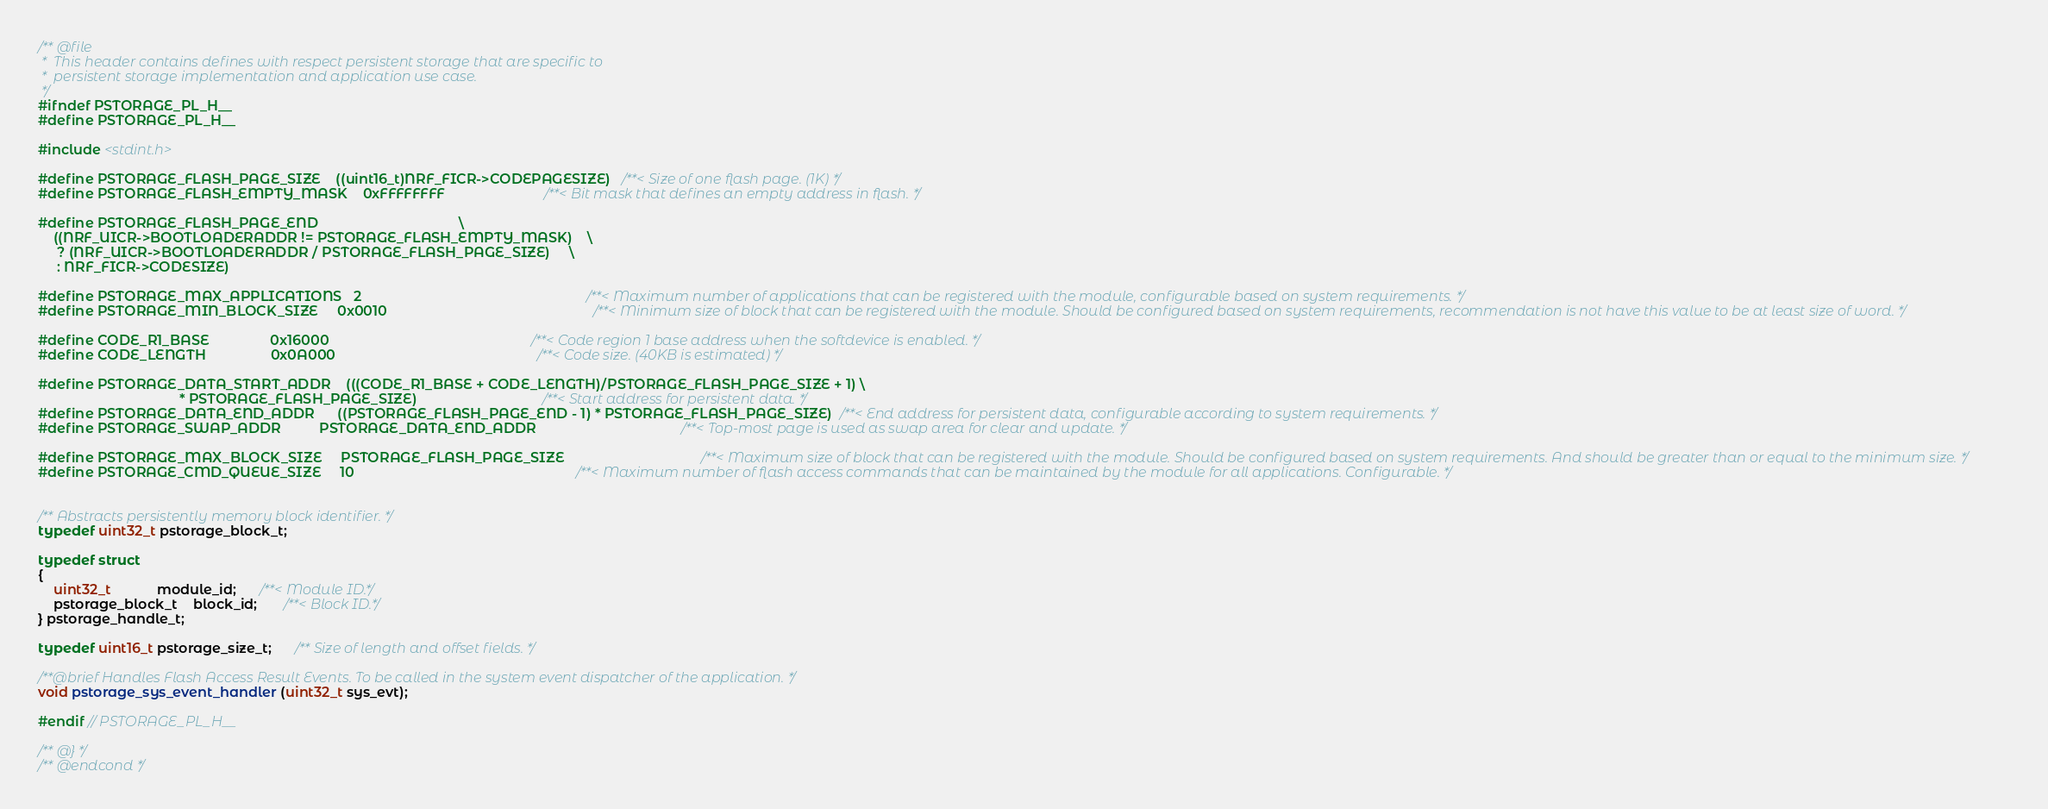Convert code to text. <code><loc_0><loc_0><loc_500><loc_500><_C_>
/** @file
 *  This header contains defines with respect persistent storage that are specific to
 *  persistent storage implementation and application use case.
 */
#ifndef PSTORAGE_PL_H__
#define PSTORAGE_PL_H__

#include <stdint.h>

#define PSTORAGE_FLASH_PAGE_SIZE    ((uint16_t)NRF_FICR->CODEPAGESIZE)   /**< Size of one flash page. (1K) */
#define PSTORAGE_FLASH_EMPTY_MASK    0xFFFFFFFF                          /**< Bit mask that defines an empty address in flash. */

#define PSTORAGE_FLASH_PAGE_END                                     \
    ((NRF_UICR->BOOTLOADERADDR != PSTORAGE_FLASH_EMPTY_MASK)    \
     ? (NRF_UICR->BOOTLOADERADDR / PSTORAGE_FLASH_PAGE_SIZE)     \
     : NRF_FICR->CODESIZE)

#define PSTORAGE_MAX_APPLICATIONS   2                                                           /**< Maximum number of applications that can be registered with the module, configurable based on system requirements. */
#define PSTORAGE_MIN_BLOCK_SIZE     0x0010                                                      /**< Minimum size of block that can be registered with the module. Should be configured based on system requirements, recommendation is not have this value to be at least size of word. */

#define CODE_R1_BASE                0x16000                                                     /**< Code region 1 base address when the softdevice is enabled. */
#define CODE_LENGTH                 0x0A000                                                     /**< Code size. (40KB is estimated) */

#define PSTORAGE_DATA_START_ADDR    (((CODE_R1_BASE + CODE_LENGTH)/PSTORAGE_FLASH_PAGE_SIZE + 1) \
                                     * PSTORAGE_FLASH_PAGE_SIZE)                                 /**< Start address for persistent data. */
#define PSTORAGE_DATA_END_ADDR      ((PSTORAGE_FLASH_PAGE_END - 1) * PSTORAGE_FLASH_PAGE_SIZE)  /**< End address for persistent data, configurable according to system requirements. */
#define PSTORAGE_SWAP_ADDR          PSTORAGE_DATA_END_ADDR                                      /**< Top-most page is used as swap area for clear and update. */

#define PSTORAGE_MAX_BLOCK_SIZE     PSTORAGE_FLASH_PAGE_SIZE                                    /**< Maximum size of block that can be registered with the module. Should be configured based on system requirements. And should be greater than or equal to the minimum size. */
#define PSTORAGE_CMD_QUEUE_SIZE     10                                                          /**< Maximum number of flash access commands that can be maintained by the module for all applications. Configurable. */


/** Abstracts persistently memory block identifier. */
typedef uint32_t pstorage_block_t;

typedef struct
{
    uint32_t            module_id;      /**< Module ID.*/
    pstorage_block_t    block_id;       /**< Block ID.*/
} pstorage_handle_t;

typedef uint16_t pstorage_size_t;      /** Size of length and offset fields. */

/**@brief Handles Flash Access Result Events. To be called in the system event dispatcher of the application. */
void pstorage_sys_event_handler (uint32_t sys_evt);

#endif // PSTORAGE_PL_H__

/** @} */
/** @endcond */
</code> 